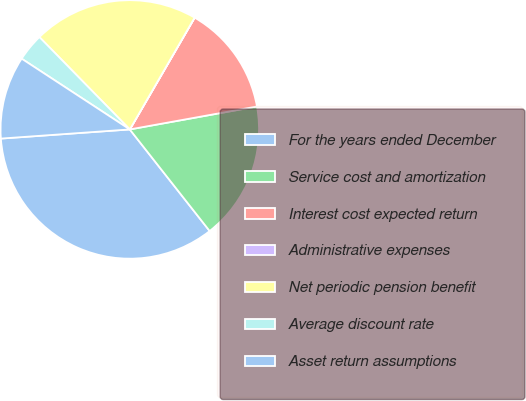Convert chart to OTSL. <chart><loc_0><loc_0><loc_500><loc_500><pie_chart><fcel>For the years ended December<fcel>Service cost and amortization<fcel>Interest cost expected return<fcel>Administrative expenses<fcel>Net periodic pension benefit<fcel>Average discount rate<fcel>Asset return assumptions<nl><fcel>34.48%<fcel>17.24%<fcel>13.79%<fcel>0.01%<fcel>20.69%<fcel>3.45%<fcel>10.35%<nl></chart> 